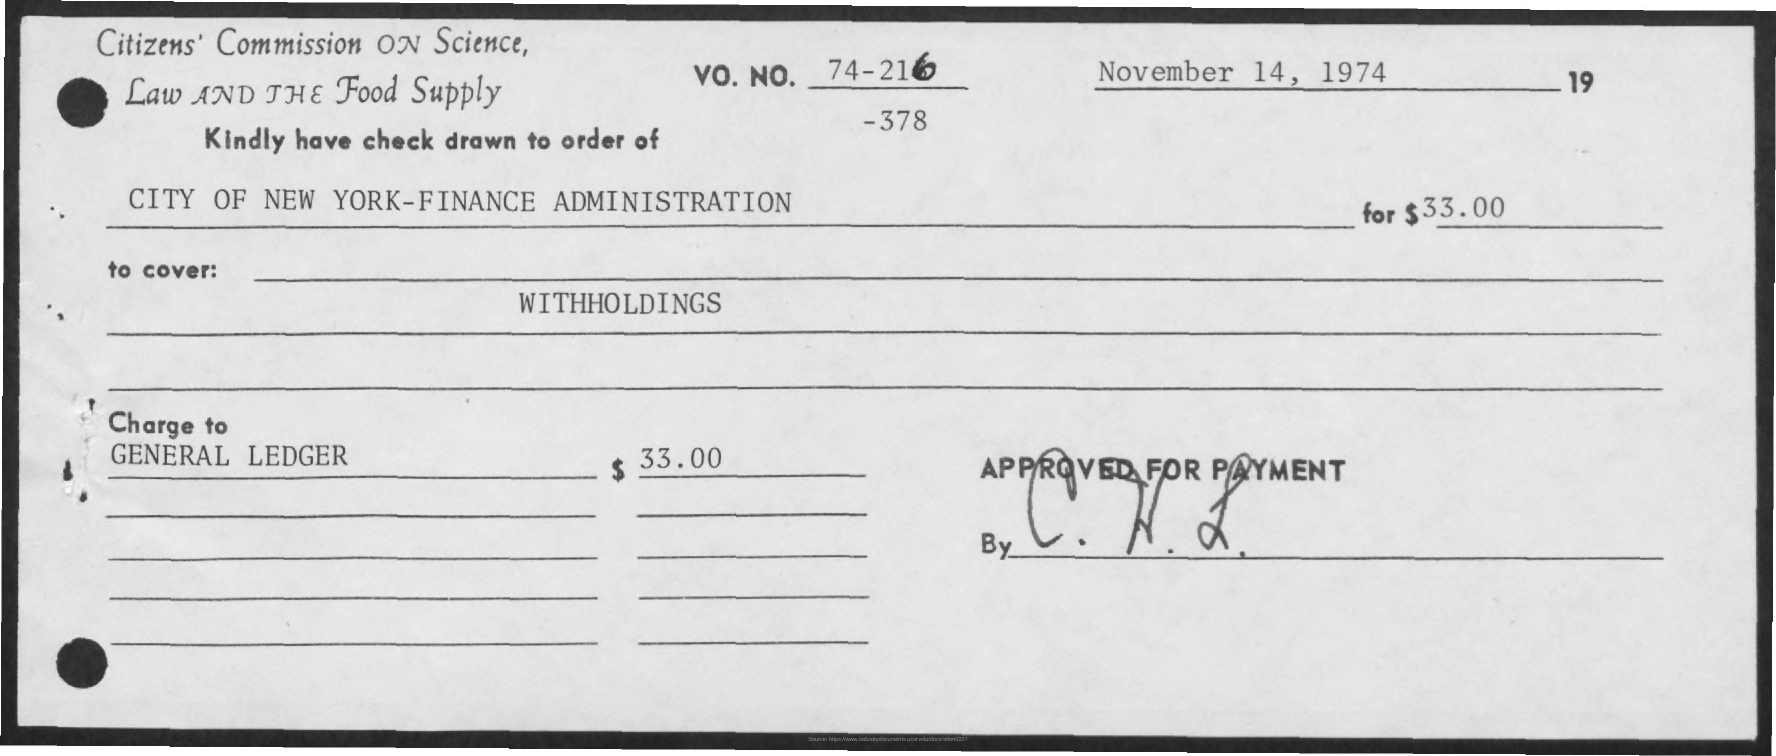What's the significance of the 'Approved for Payment' stamp? The 'Approved for Payment' stamp, along with a signature, indicates that the cheque has been reviewed and authorized for payment by an official or someone with the requisite authority within the organization. It's a necessary step in the processing of financial documents to ensure legitimacy and proper authorization. 